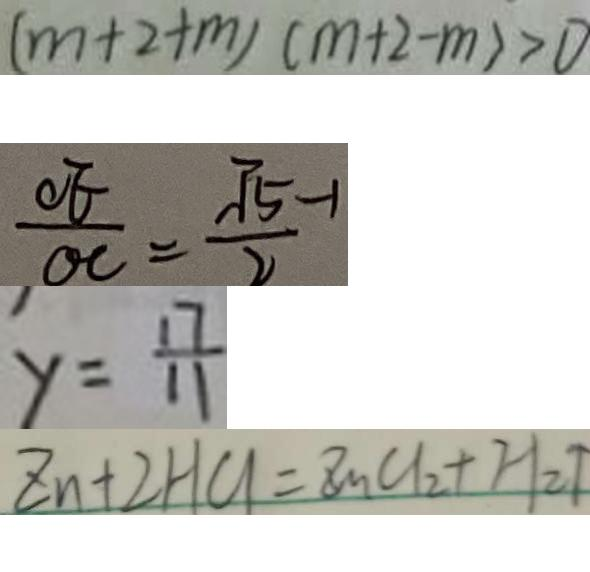Convert formula to latex. <formula><loc_0><loc_0><loc_500><loc_500>( m + 2 + m ) ( m + 2 - m ) > 0 
 \frac { O E } { O C } = \frac { \sqrt { 5 } - 1 } { 2 } 
 y = \frac { 1 7 } { 1 1 } 
 z n + 2 H C l = z n C l _ { 2 } + H _ { 2 } \uparrow</formula> 